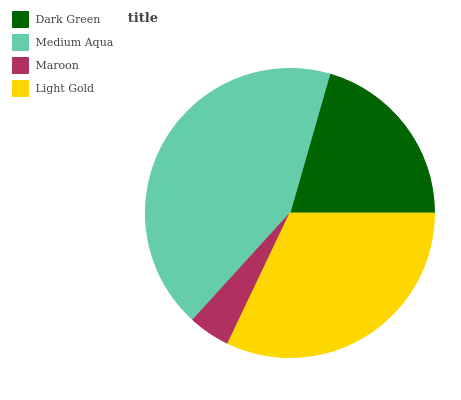Is Maroon the minimum?
Answer yes or no. Yes. Is Medium Aqua the maximum?
Answer yes or no. Yes. Is Medium Aqua the minimum?
Answer yes or no. No. Is Maroon the maximum?
Answer yes or no. No. Is Medium Aqua greater than Maroon?
Answer yes or no. Yes. Is Maroon less than Medium Aqua?
Answer yes or no. Yes. Is Maroon greater than Medium Aqua?
Answer yes or no. No. Is Medium Aqua less than Maroon?
Answer yes or no. No. Is Light Gold the high median?
Answer yes or no. Yes. Is Dark Green the low median?
Answer yes or no. Yes. Is Medium Aqua the high median?
Answer yes or no. No. Is Light Gold the low median?
Answer yes or no. No. 